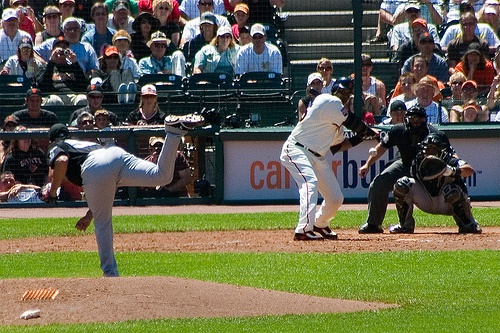Describe the objects in this image and their specific colors. I can see people in black, gray, maroon, and white tones, people in black, gray, white, and maroon tones, people in black, darkgray, white, and tan tones, people in black, gray, and white tones, and people in black, gray, maroon, and darkgray tones in this image. 